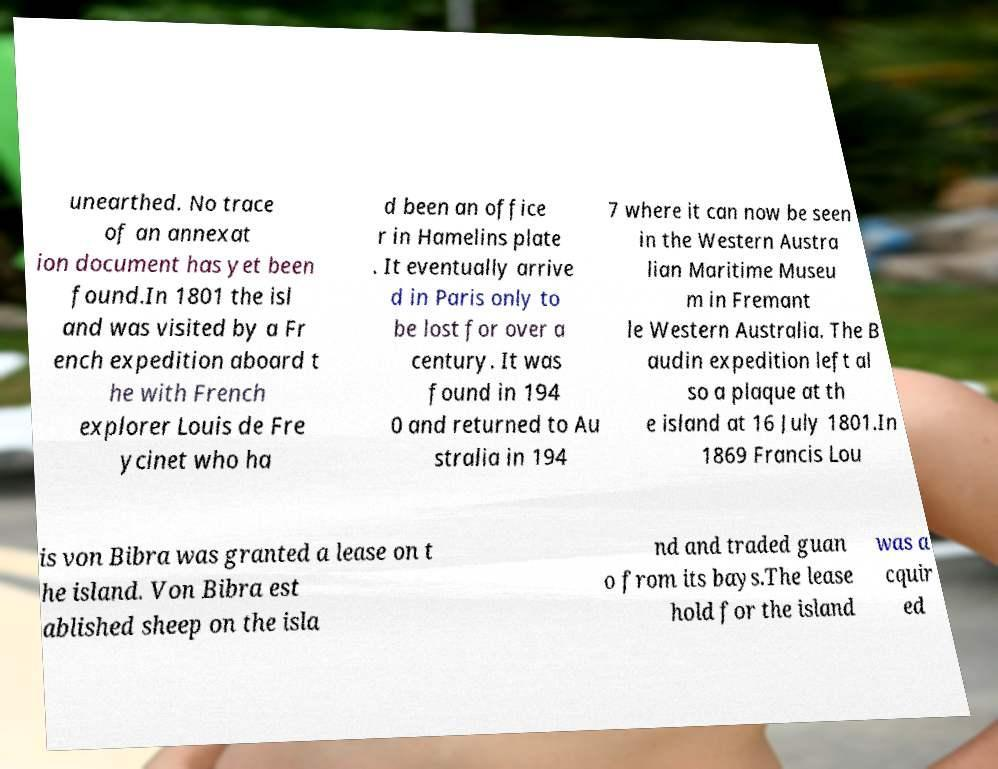Can you read and provide the text displayed in the image?This photo seems to have some interesting text. Can you extract and type it out for me? unearthed. No trace of an annexat ion document has yet been found.In 1801 the isl and was visited by a Fr ench expedition aboard t he with French explorer Louis de Fre ycinet who ha d been an office r in Hamelins plate . It eventually arrive d in Paris only to be lost for over a century. It was found in 194 0 and returned to Au stralia in 194 7 where it can now be seen in the Western Austra lian Maritime Museu m in Fremant le Western Australia. The B audin expedition left al so a plaque at th e island at 16 July 1801.In 1869 Francis Lou is von Bibra was granted a lease on t he island. Von Bibra est ablished sheep on the isla nd and traded guan o from its bays.The lease hold for the island was a cquir ed 